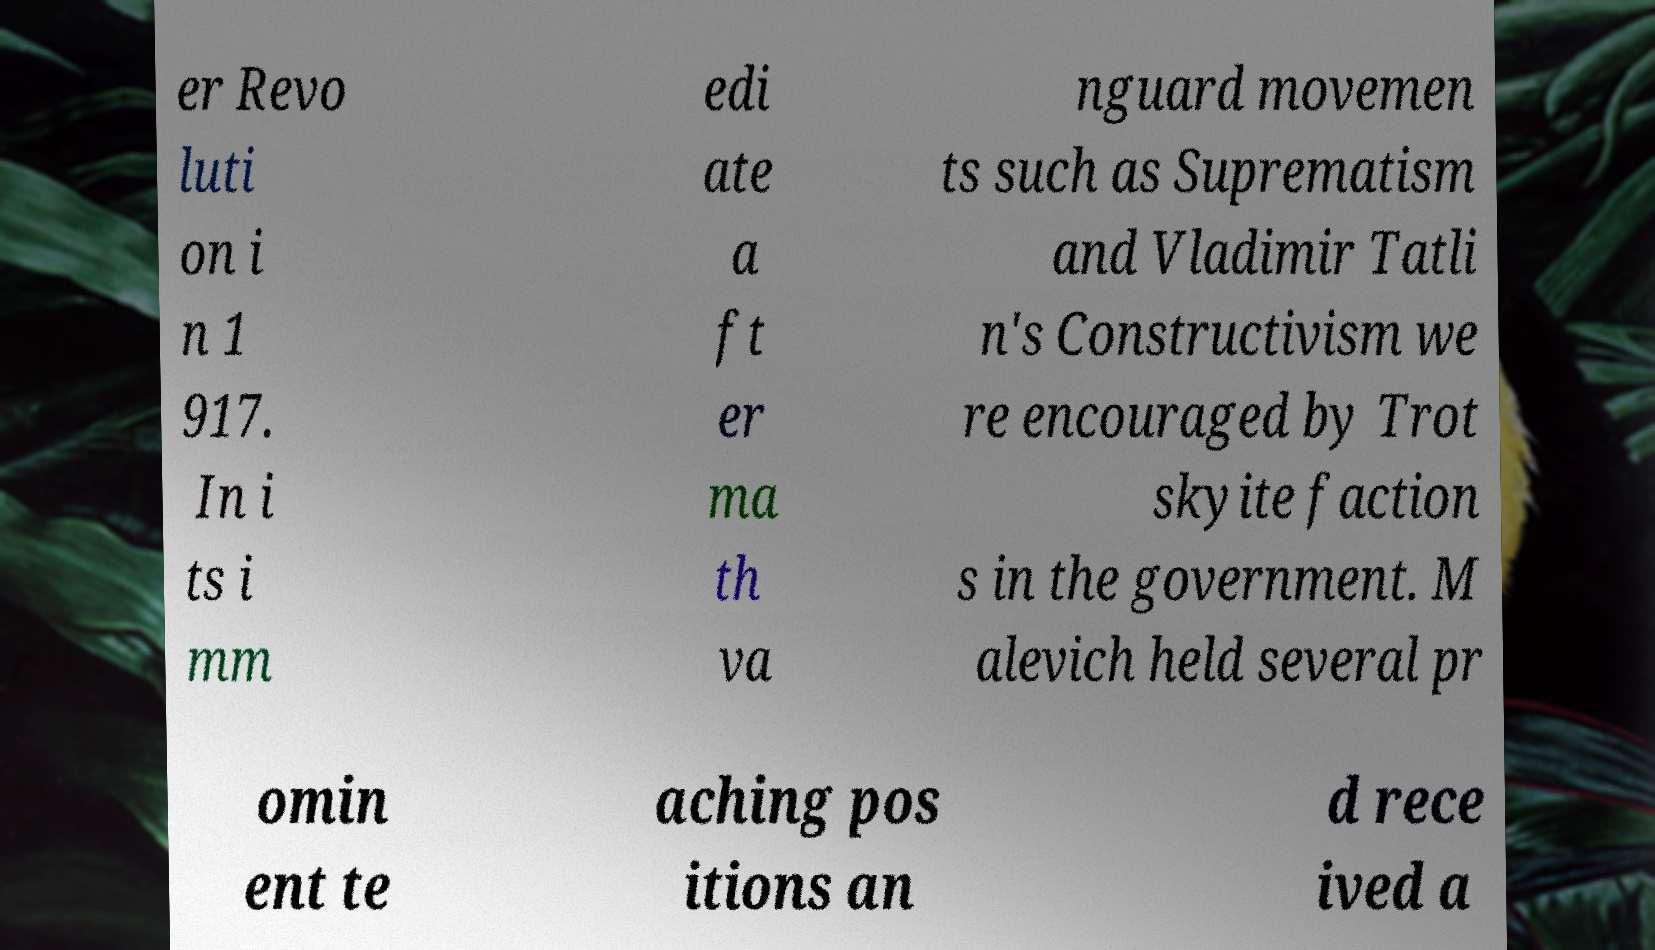There's text embedded in this image that I need extracted. Can you transcribe it verbatim? er Revo luti on i n 1 917. In i ts i mm edi ate a ft er ma th va nguard movemen ts such as Suprematism and Vladimir Tatli n's Constructivism we re encouraged by Trot skyite faction s in the government. M alevich held several pr omin ent te aching pos itions an d rece ived a 